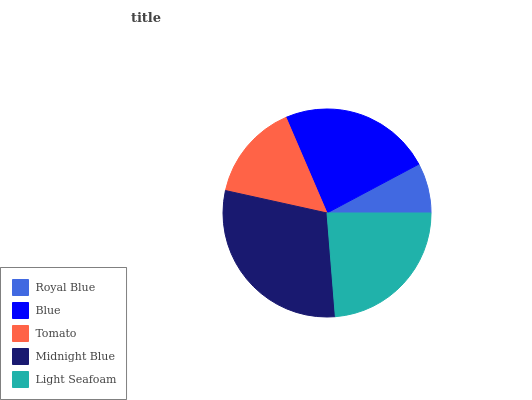Is Royal Blue the minimum?
Answer yes or no. Yes. Is Midnight Blue the maximum?
Answer yes or no. Yes. Is Blue the minimum?
Answer yes or no. No. Is Blue the maximum?
Answer yes or no. No. Is Blue greater than Royal Blue?
Answer yes or no. Yes. Is Royal Blue less than Blue?
Answer yes or no. Yes. Is Royal Blue greater than Blue?
Answer yes or no. No. Is Blue less than Royal Blue?
Answer yes or no. No. Is Blue the high median?
Answer yes or no. Yes. Is Blue the low median?
Answer yes or no. Yes. Is Royal Blue the high median?
Answer yes or no. No. Is Light Seafoam the low median?
Answer yes or no. No. 